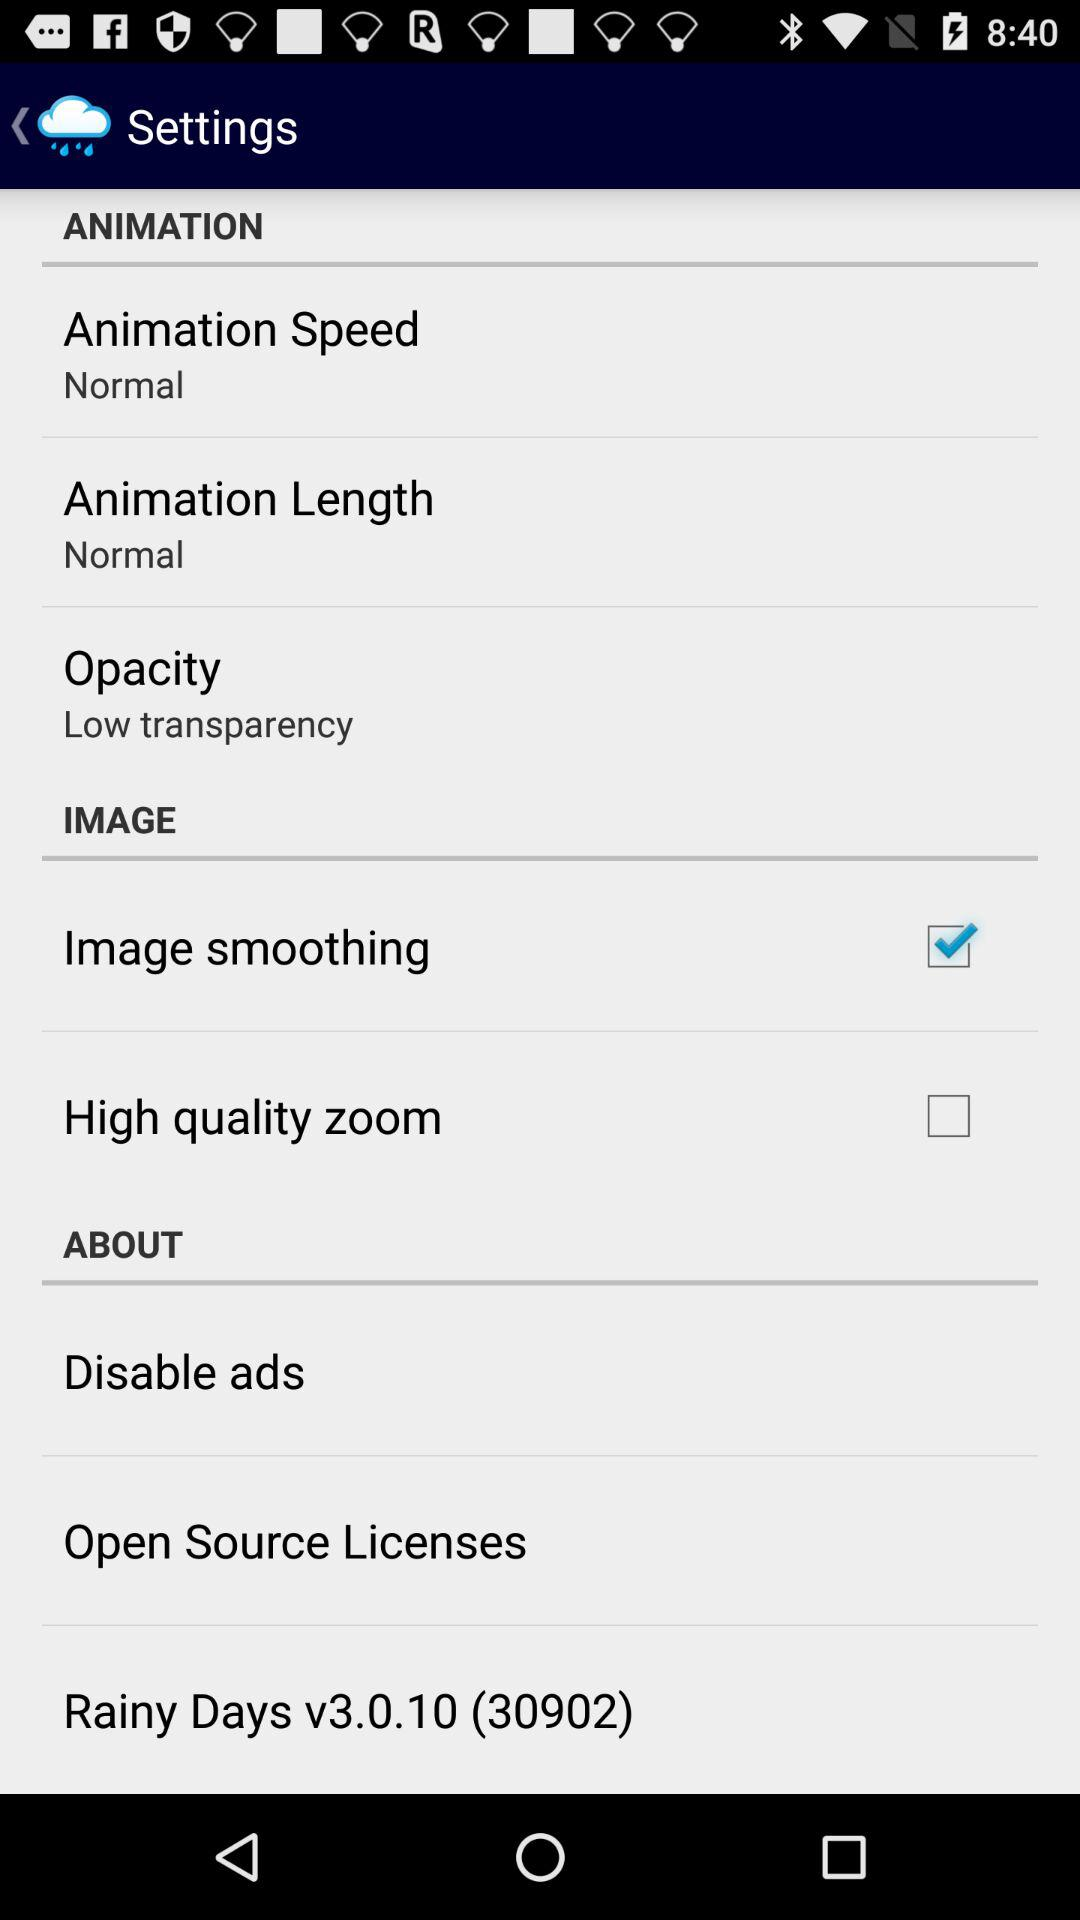What is the version of "Rainy Days"? The version is v3.0.10 (30902). 